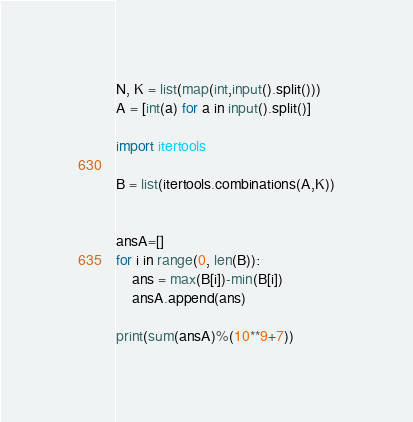<code> <loc_0><loc_0><loc_500><loc_500><_Python_>N, K = list(map(int,input().split()))
A = [int(a) for a in input().split()]

import itertools

B = list(itertools.combinations(A,K))


ansA=[]
for i in range(0, len(B)):
    ans = max(B[i])-min(B[i])
    ansA.append(ans)

print(sum(ansA)%(10**9+7))    
</code> 